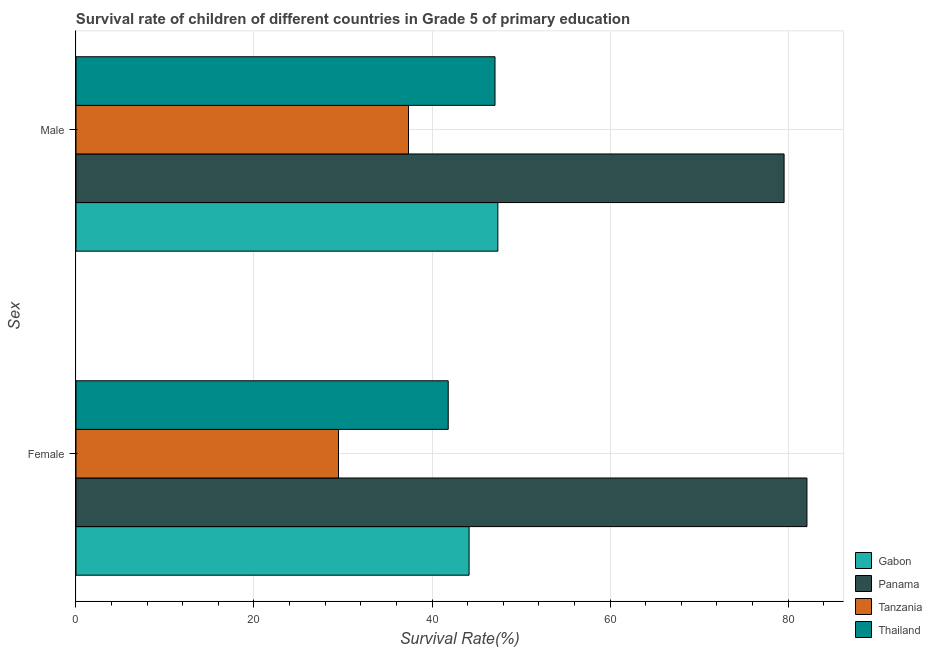How many different coloured bars are there?
Provide a short and direct response. 4. Are the number of bars per tick equal to the number of legend labels?
Offer a terse response. Yes. Are the number of bars on each tick of the Y-axis equal?
Ensure brevity in your answer.  Yes. How many bars are there on the 1st tick from the bottom?
Give a very brief answer. 4. What is the survival rate of male students in primary education in Thailand?
Your answer should be compact. 47.08. Across all countries, what is the maximum survival rate of male students in primary education?
Give a very brief answer. 79.56. Across all countries, what is the minimum survival rate of male students in primary education?
Your answer should be very brief. 37.36. In which country was the survival rate of male students in primary education maximum?
Your response must be concise. Panama. In which country was the survival rate of female students in primary education minimum?
Give a very brief answer. Tanzania. What is the total survival rate of female students in primary education in the graph?
Ensure brevity in your answer.  197.62. What is the difference between the survival rate of female students in primary education in Tanzania and that in Thailand?
Keep it short and to the point. -12.33. What is the difference between the survival rate of female students in primary education in Gabon and the survival rate of male students in primary education in Thailand?
Ensure brevity in your answer.  -2.91. What is the average survival rate of female students in primary education per country?
Make the answer very short. 49.4. What is the difference between the survival rate of female students in primary education and survival rate of male students in primary education in Thailand?
Offer a very short reply. -5.26. What is the ratio of the survival rate of male students in primary education in Gabon to that in Tanzania?
Give a very brief answer. 1.27. What does the 2nd bar from the top in Male represents?
Make the answer very short. Tanzania. What does the 1st bar from the bottom in Female represents?
Ensure brevity in your answer.  Gabon. How many bars are there?
Your response must be concise. 8. Are all the bars in the graph horizontal?
Provide a short and direct response. Yes. Are the values on the major ticks of X-axis written in scientific E-notation?
Keep it short and to the point. No. Does the graph contain any zero values?
Ensure brevity in your answer.  No. Does the graph contain grids?
Keep it short and to the point. Yes. Where does the legend appear in the graph?
Give a very brief answer. Bottom right. How many legend labels are there?
Provide a succinct answer. 4. What is the title of the graph?
Provide a succinct answer. Survival rate of children of different countries in Grade 5 of primary education. What is the label or title of the X-axis?
Ensure brevity in your answer.  Survival Rate(%). What is the label or title of the Y-axis?
Your answer should be compact. Sex. What is the Survival Rate(%) of Gabon in Female?
Ensure brevity in your answer.  44.17. What is the Survival Rate(%) of Panama in Female?
Your response must be concise. 82.13. What is the Survival Rate(%) of Tanzania in Female?
Give a very brief answer. 29.5. What is the Survival Rate(%) of Thailand in Female?
Offer a very short reply. 41.82. What is the Survival Rate(%) of Gabon in Male?
Keep it short and to the point. 47.4. What is the Survival Rate(%) in Panama in Male?
Your answer should be very brief. 79.56. What is the Survival Rate(%) in Tanzania in Male?
Your answer should be very brief. 37.36. What is the Survival Rate(%) of Thailand in Male?
Provide a short and direct response. 47.08. Across all Sex, what is the maximum Survival Rate(%) in Gabon?
Provide a succinct answer. 47.4. Across all Sex, what is the maximum Survival Rate(%) in Panama?
Your answer should be very brief. 82.13. Across all Sex, what is the maximum Survival Rate(%) of Tanzania?
Make the answer very short. 37.36. Across all Sex, what is the maximum Survival Rate(%) of Thailand?
Your response must be concise. 47.08. Across all Sex, what is the minimum Survival Rate(%) of Gabon?
Your answer should be compact. 44.17. Across all Sex, what is the minimum Survival Rate(%) of Panama?
Keep it short and to the point. 79.56. Across all Sex, what is the minimum Survival Rate(%) of Tanzania?
Give a very brief answer. 29.5. Across all Sex, what is the minimum Survival Rate(%) in Thailand?
Provide a succinct answer. 41.82. What is the total Survival Rate(%) in Gabon in the graph?
Make the answer very short. 91.57. What is the total Survival Rate(%) in Panama in the graph?
Make the answer very short. 161.69. What is the total Survival Rate(%) of Tanzania in the graph?
Offer a terse response. 66.85. What is the total Survival Rate(%) in Thailand in the graph?
Provide a short and direct response. 88.9. What is the difference between the Survival Rate(%) of Gabon in Female and that in Male?
Keep it short and to the point. -3.23. What is the difference between the Survival Rate(%) of Panama in Female and that in Male?
Keep it short and to the point. 2.57. What is the difference between the Survival Rate(%) of Tanzania in Female and that in Male?
Provide a short and direct response. -7.86. What is the difference between the Survival Rate(%) in Thailand in Female and that in Male?
Offer a very short reply. -5.26. What is the difference between the Survival Rate(%) in Gabon in Female and the Survival Rate(%) in Panama in Male?
Offer a terse response. -35.39. What is the difference between the Survival Rate(%) of Gabon in Female and the Survival Rate(%) of Tanzania in Male?
Your response must be concise. 6.81. What is the difference between the Survival Rate(%) in Gabon in Female and the Survival Rate(%) in Thailand in Male?
Give a very brief answer. -2.91. What is the difference between the Survival Rate(%) in Panama in Female and the Survival Rate(%) in Tanzania in Male?
Offer a very short reply. 44.77. What is the difference between the Survival Rate(%) of Panama in Female and the Survival Rate(%) of Thailand in Male?
Give a very brief answer. 35.05. What is the difference between the Survival Rate(%) in Tanzania in Female and the Survival Rate(%) in Thailand in Male?
Give a very brief answer. -17.58. What is the average Survival Rate(%) of Gabon per Sex?
Give a very brief answer. 45.78. What is the average Survival Rate(%) in Panama per Sex?
Your response must be concise. 80.85. What is the average Survival Rate(%) in Tanzania per Sex?
Keep it short and to the point. 33.43. What is the average Survival Rate(%) in Thailand per Sex?
Ensure brevity in your answer.  44.45. What is the difference between the Survival Rate(%) in Gabon and Survival Rate(%) in Panama in Female?
Give a very brief answer. -37.96. What is the difference between the Survival Rate(%) of Gabon and Survival Rate(%) of Tanzania in Female?
Keep it short and to the point. 14.67. What is the difference between the Survival Rate(%) of Gabon and Survival Rate(%) of Thailand in Female?
Keep it short and to the point. 2.34. What is the difference between the Survival Rate(%) of Panama and Survival Rate(%) of Tanzania in Female?
Make the answer very short. 52.63. What is the difference between the Survival Rate(%) of Panama and Survival Rate(%) of Thailand in Female?
Provide a short and direct response. 40.31. What is the difference between the Survival Rate(%) of Tanzania and Survival Rate(%) of Thailand in Female?
Your response must be concise. -12.33. What is the difference between the Survival Rate(%) in Gabon and Survival Rate(%) in Panama in Male?
Provide a short and direct response. -32.16. What is the difference between the Survival Rate(%) of Gabon and Survival Rate(%) of Tanzania in Male?
Your answer should be compact. 10.04. What is the difference between the Survival Rate(%) of Gabon and Survival Rate(%) of Thailand in Male?
Offer a very short reply. 0.32. What is the difference between the Survival Rate(%) in Panama and Survival Rate(%) in Tanzania in Male?
Offer a very short reply. 42.2. What is the difference between the Survival Rate(%) in Panama and Survival Rate(%) in Thailand in Male?
Your answer should be compact. 32.48. What is the difference between the Survival Rate(%) in Tanzania and Survival Rate(%) in Thailand in Male?
Make the answer very short. -9.72. What is the ratio of the Survival Rate(%) of Gabon in Female to that in Male?
Keep it short and to the point. 0.93. What is the ratio of the Survival Rate(%) of Panama in Female to that in Male?
Ensure brevity in your answer.  1.03. What is the ratio of the Survival Rate(%) of Tanzania in Female to that in Male?
Ensure brevity in your answer.  0.79. What is the ratio of the Survival Rate(%) in Thailand in Female to that in Male?
Your answer should be compact. 0.89. What is the difference between the highest and the second highest Survival Rate(%) in Gabon?
Make the answer very short. 3.23. What is the difference between the highest and the second highest Survival Rate(%) in Panama?
Your answer should be compact. 2.57. What is the difference between the highest and the second highest Survival Rate(%) in Tanzania?
Your answer should be compact. 7.86. What is the difference between the highest and the second highest Survival Rate(%) of Thailand?
Ensure brevity in your answer.  5.26. What is the difference between the highest and the lowest Survival Rate(%) of Gabon?
Offer a very short reply. 3.23. What is the difference between the highest and the lowest Survival Rate(%) of Panama?
Your answer should be compact. 2.57. What is the difference between the highest and the lowest Survival Rate(%) of Tanzania?
Make the answer very short. 7.86. What is the difference between the highest and the lowest Survival Rate(%) of Thailand?
Give a very brief answer. 5.26. 